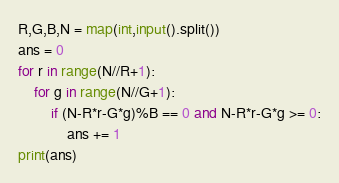Convert code to text. <code><loc_0><loc_0><loc_500><loc_500><_Python_>R,G,B,N = map(int,input().split())
ans = 0
for r in range(N//R+1):
    for g in range(N//G+1):
        if (N-R*r-G*g)%B == 0 and N-R*r-G*g >= 0:
            ans += 1
print(ans)</code> 